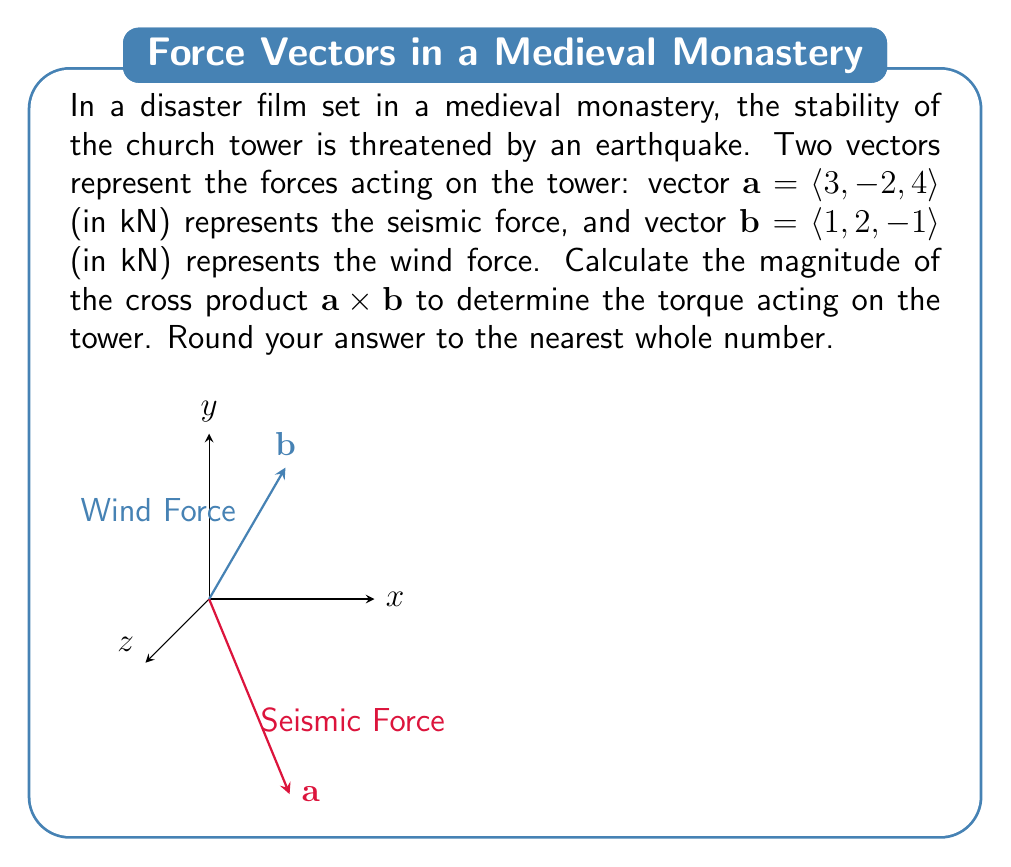Show me your answer to this math problem. Let's approach this step-by-step:

1) The cross product of two vectors $\mathbf{a} = \langle a_1, a_2, a_3 \rangle$ and $\mathbf{b} = \langle b_1, b_2, b_3 \rangle$ is defined as:

   $$\mathbf{a} \times \mathbf{b} = \langle a_2b_3 - a_3b_2, a_3b_1 - a_1b_3, a_1b_2 - a_2b_1 \rangle$$

2) In our case, $\mathbf{a} = \langle 3, -2, 4 \rangle$ and $\mathbf{b} = \langle 1, 2, -1 \rangle$. Let's substitute these values:

   $$\mathbf{a} \times \mathbf{b} = \langle (-2)(-1) - (4)(2), (4)(1) - (3)(-1), (3)(2) - (-2)(1) \rangle$$

3) Let's calculate each component:
   
   $$\mathbf{a} \times \mathbf{b} = \langle 2 - 8, 4 + 3, 6 + 2 \rangle$$

4) Simplifying:

   $$\mathbf{a} \times \mathbf{b} = \langle -6, 7, 8 \rangle$$

5) The magnitude of this vector is given by the square root of the sum of the squares of its components:

   $$|\mathbf{a} \times \mathbf{b}| = \sqrt{(-6)^2 + 7^2 + 8^2}$$

6) Calculating:

   $$|\mathbf{a} \times \mathbf{b}| = \sqrt{36 + 49 + 64} = \sqrt{149} \approx 12.21$$

7) Rounding to the nearest whole number:

   $$|\mathbf{a} \times \mathbf{b}| \approx 12 \text{ kN⋅m}$$

The magnitude of the cross product represents the torque acting on the tower, which could affect its stability during the earthquake in the film.
Answer: 12 kN⋅m 